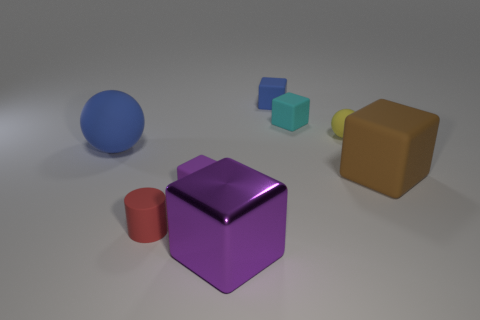There is a big sphere; is its color the same as the large cube that is on the left side of the cyan matte object?
Offer a very short reply. No. Are there any cyan things behind the big brown matte block?
Keep it short and to the point. Yes. Are the brown object and the blue ball made of the same material?
Keep it short and to the point. Yes. What material is the purple cube that is the same size as the brown object?
Ensure brevity in your answer.  Metal. What number of things are rubber blocks behind the tiny yellow sphere or big cyan balls?
Your response must be concise. 2. Are there the same number of big brown rubber cubes that are behind the blue rubber sphere and small metallic cylinders?
Provide a short and direct response. Yes. Do the big sphere and the tiny matte sphere have the same color?
Make the answer very short. No. There is a large object that is right of the large ball and behind the tiny purple cube; what color is it?
Make the answer very short. Brown. What number of cubes are small green objects or large brown things?
Make the answer very short. 1. Are there fewer yellow matte balls that are on the left side of the purple matte cube than small yellow cubes?
Keep it short and to the point. No. 